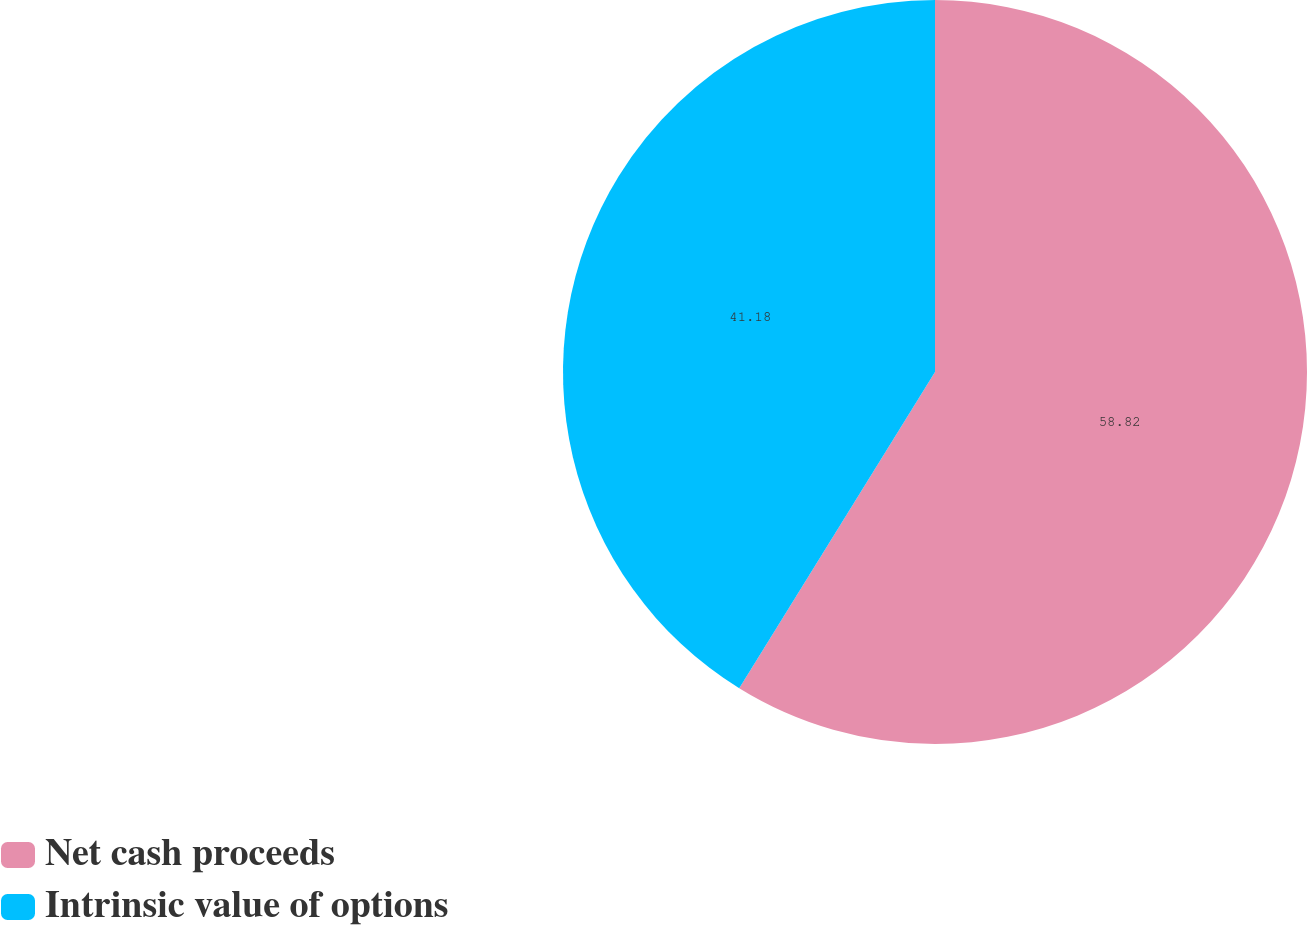Convert chart to OTSL. <chart><loc_0><loc_0><loc_500><loc_500><pie_chart><fcel>Net cash proceeds<fcel>Intrinsic value of options<nl><fcel>58.82%<fcel>41.18%<nl></chart> 